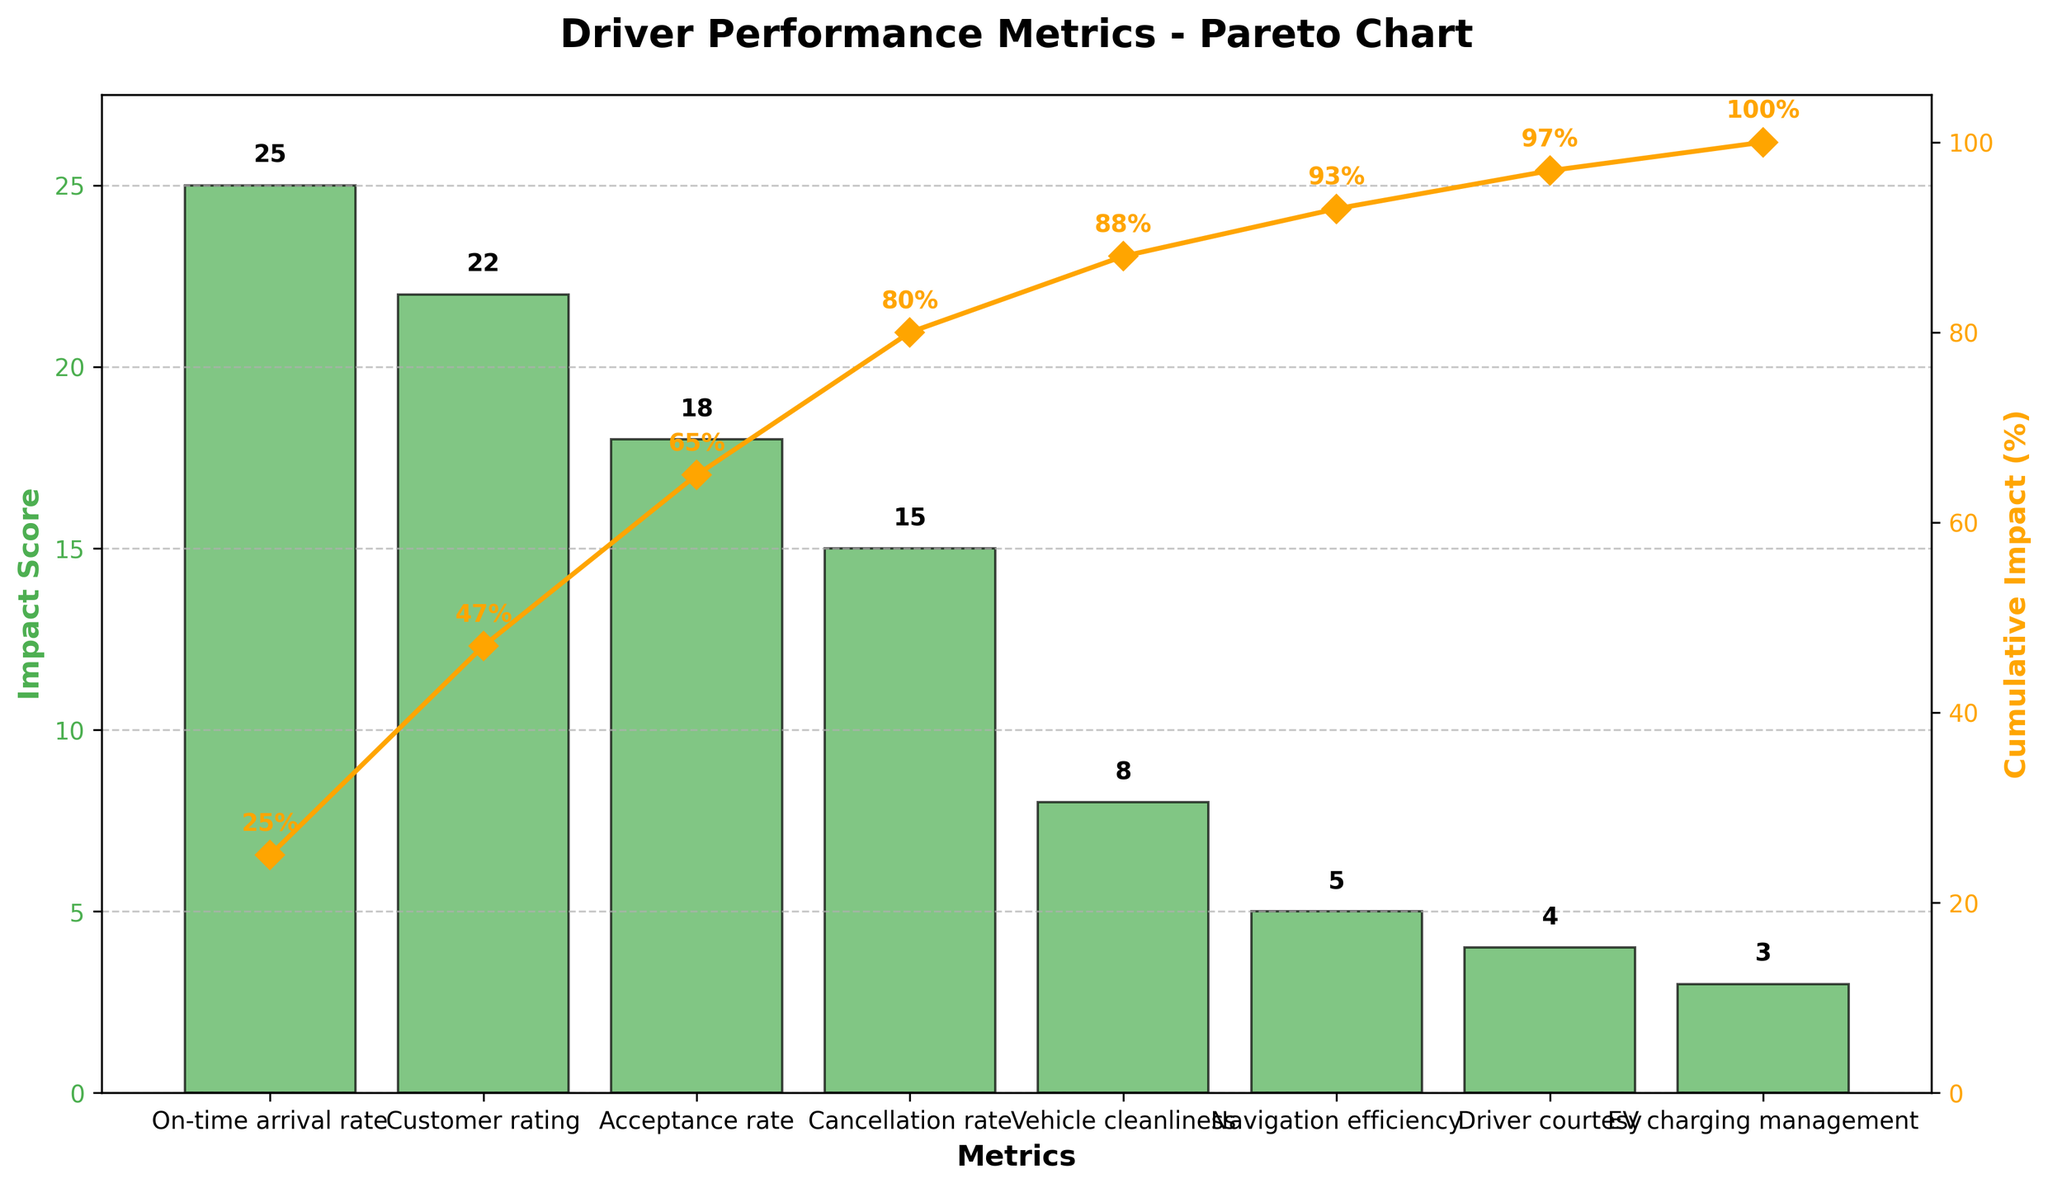What is the title of the chart? The title is shown at the top of the chart. It reads "Driver Performance Metrics - Pareto Chart".
Answer: Driver Performance Metrics - Pareto Chart Which metric has the highest impact score? The highest bar on the chart corresponds to the "On-time arrival rate" metric, which has the highest impact score.
Answer: On-time arrival rate What is the cumulative impact percentage after adding the "Customer rating" metric? The cumulative impact percentage reaches 47% after adding the "Customer rating" metric, as indicated by the cumulative line.
Answer: 47% How many metrics have an impact score greater than 20? By inspecting the height of the bars, "On-time arrival rate" (25) and "Customer rating" (22) have impact scores greater than 20.
Answer: 2 What is the difference in cumulative impact between "Cancellation rate" and "Vehicle cleanliness"? The cumulative impact for "Cancellation rate" is 80%, and for "Vehicle cleanliness" it is 88%. The difference is 88% - 80% = 8%.
Answer: 8% What is the total impact score of the three highest metrics combined? The impact scores of the three highest metrics are "On-time arrival rate" (25), "Customer rating" (22), and "Acceptance rate" (18). Summing them up, 25 + 22 + 18 = 65.
Answer: 65 How does the cumulative impact percentage change from "Acceptance rate" to "Cancellation rate"? The cumulative impact percentage changes from 65% at "Acceptance rate" to 80% at "Cancellation rate". The change is 80% - 65% = 15%.
Answer: 15% Which metric has the lowest individual impact score? The shortest bar on the chart corresponds to "EV charging management" with an impact score of 3.
Answer: EV charging management What is the cumulative impact percentage at "Driver courtesy"? The cumulative impact percentage at "Driver courtesy" is marked by the line and text on the chart as 97%.
Answer: 97% Which metric is just below "Vehicle cleanliness" in the impact score ranking? Below "Vehicle cleanliness" (8), the next metric is "Navigation efficiency" with an impact score of 5.
Answer: Navigation efficiency 